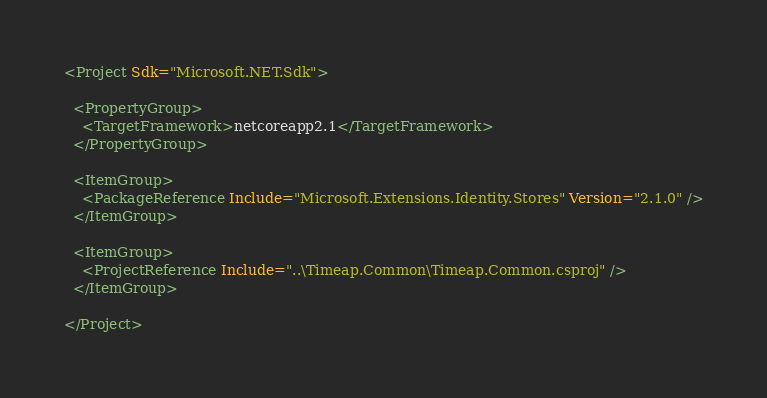<code> <loc_0><loc_0><loc_500><loc_500><_XML_><Project Sdk="Microsoft.NET.Sdk">

  <PropertyGroup>
    <TargetFramework>netcoreapp2.1</TargetFramework>
  </PropertyGroup>

  <ItemGroup>
    <PackageReference Include="Microsoft.Extensions.Identity.Stores" Version="2.1.0" />
  </ItemGroup>

  <ItemGroup>
    <ProjectReference Include="..\Timeap.Common\Timeap.Common.csproj" />
  </ItemGroup>

</Project>
</code> 